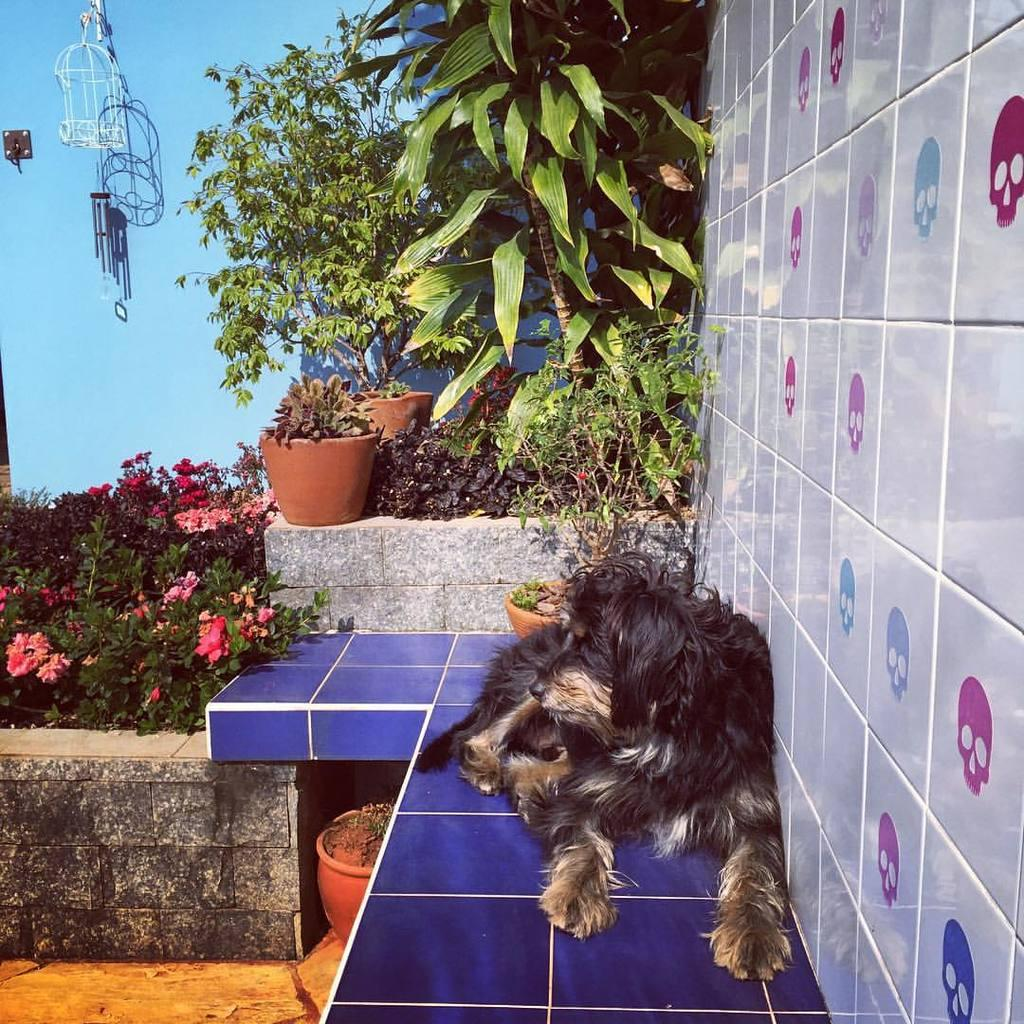What animal is sitting in the image? There is a dog sitting in the image. What can be seen in the background of the image? In the background of the image, there are plant pots, flowers, plants, a wall, and other objects. Can you describe the plants in the background of the image? The plants in the background of the image include flowers and other plants. What type of music is the band playing in the background of the image? There is no band present in the image, so it is not possible to determine what type of music they might be playing. 